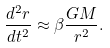Convert formula to latex. <formula><loc_0><loc_0><loc_500><loc_500>\frac { d ^ { 2 } r } { d t ^ { 2 } } \approx \beta \frac { G M } { r ^ { 2 } } .</formula> 